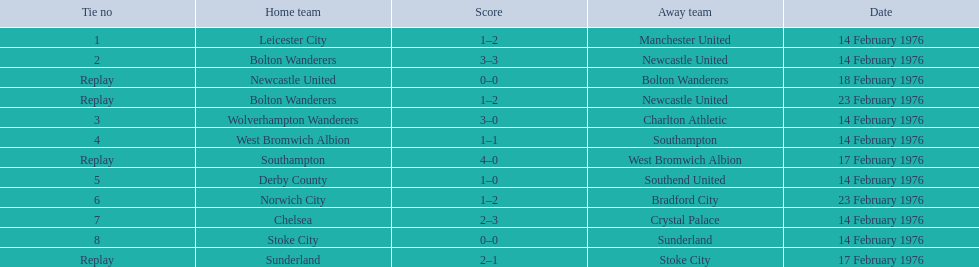What teams are featured in the game at the top of the table? Leicester City, Manchester United. Which of these two is the home team? Leicester City. Parse the table in full. {'header': ['Tie no', 'Home team', 'Score', 'Away team', 'Date'], 'rows': [['1', 'Leicester City', '1–2', 'Manchester United', '14 February 1976'], ['2', 'Bolton Wanderers', '3–3', 'Newcastle United', '14 February 1976'], ['Replay', 'Newcastle United', '0–0', 'Bolton Wanderers', '18 February 1976'], ['Replay', 'Bolton Wanderers', '1–2', 'Newcastle United', '23 February 1976'], ['3', 'Wolverhampton Wanderers', '3–0', 'Charlton Athletic', '14 February 1976'], ['4', 'West Bromwich Albion', '1–1', 'Southampton', '14 February 1976'], ['Replay', 'Southampton', '4–0', 'West Bromwich Albion', '17 February 1976'], ['5', 'Derby County', '1–0', 'Southend United', '14 February 1976'], ['6', 'Norwich City', '1–2', 'Bradford City', '23 February 1976'], ['7', 'Chelsea', '2–3', 'Crystal Palace', '14 February 1976'], ['8', 'Stoke City', '0–0', 'Sunderland', '14 February 1976'], ['Replay', 'Sunderland', '2–1', 'Stoke City', '17 February 1976']]} What is the match at the peak of the chart? 1. Who is the host team for this match? Leicester City. 